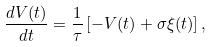Convert formula to latex. <formula><loc_0><loc_0><loc_500><loc_500>\frac { d V ( t ) } { d t } = \frac { 1 } { \tau } \left [ - V ( t ) + \sigma \xi ( t ) \right ] ,</formula> 